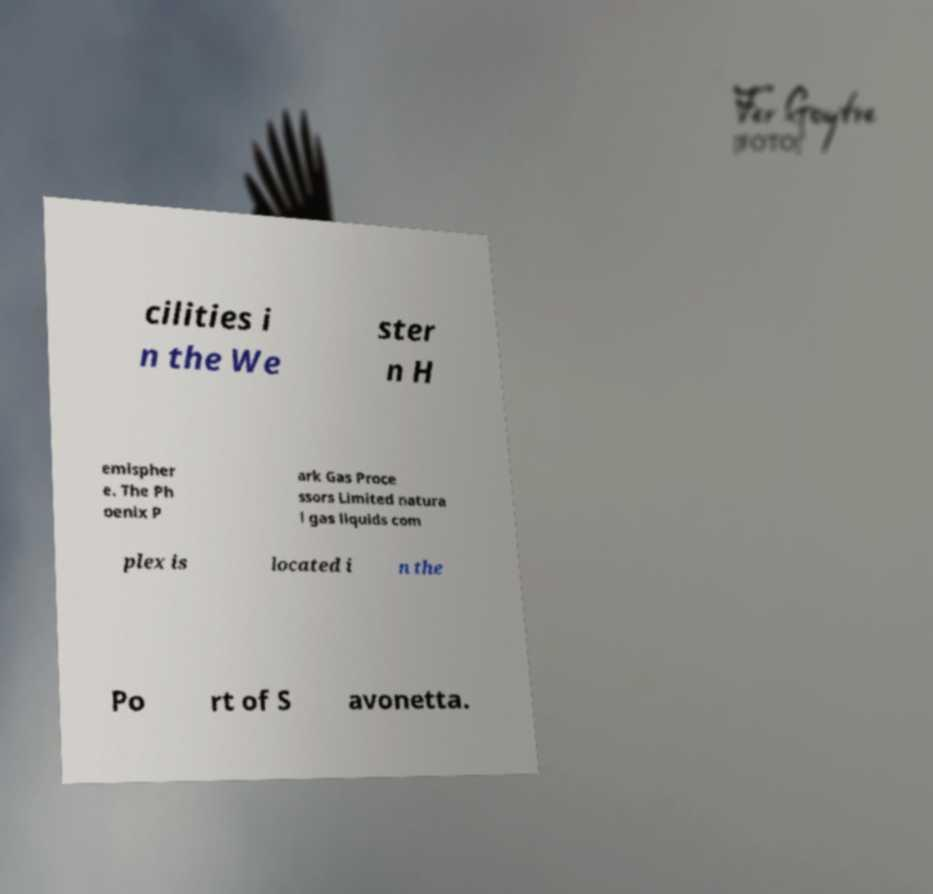Can you read and provide the text displayed in the image?This photo seems to have some interesting text. Can you extract and type it out for me? cilities i n the We ster n H emispher e. The Ph oenix P ark Gas Proce ssors Limited natura l gas liquids com plex is located i n the Po rt of S avonetta. 